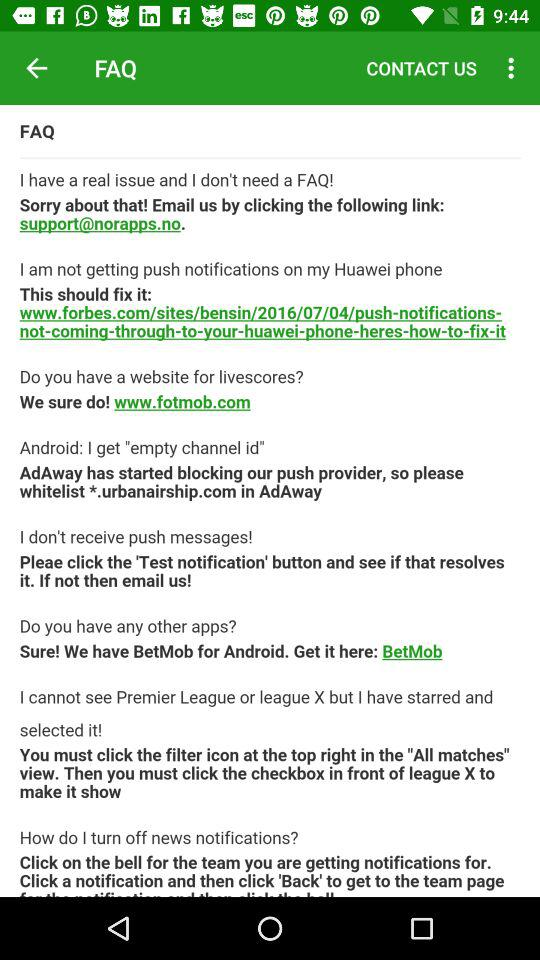Which link should we use to fix it? The link is www.forbes.com/sites/bensin/2016/07/04/push-notifications- not-coming-through-to-your-huawei-phone-heres-how-to-fix-it. 